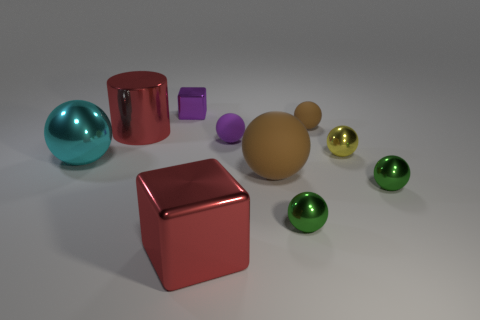There is a big metallic thing that is the same color as the large cylinder; what is its shape?
Your response must be concise. Cube. Is the number of brown rubber objects that are right of the yellow thing the same as the number of rubber things behind the purple metal thing?
Your answer should be very brief. Yes. How many things are either large yellow rubber balls or rubber objects that are behind the big cyan metallic object?
Provide a short and direct response. 2. There is a object that is both behind the red metal cylinder and in front of the small block; what shape is it?
Your answer should be very brief. Sphere. There is a red object to the left of the big red object that is on the right side of the small purple shiny thing; what is it made of?
Your response must be concise. Metal. Are the brown sphere that is behind the tiny yellow sphere and the small purple sphere made of the same material?
Offer a very short reply. Yes. There is a green metallic thing left of the tiny brown matte object; how big is it?
Your answer should be very brief. Small. Is there a brown matte thing left of the big red object in front of the yellow object?
Keep it short and to the point. No. There is a block that is in front of the purple metallic object; is its color the same as the small rubber object to the left of the small brown object?
Your answer should be compact. No. The cylinder is what color?
Offer a very short reply. Red. 